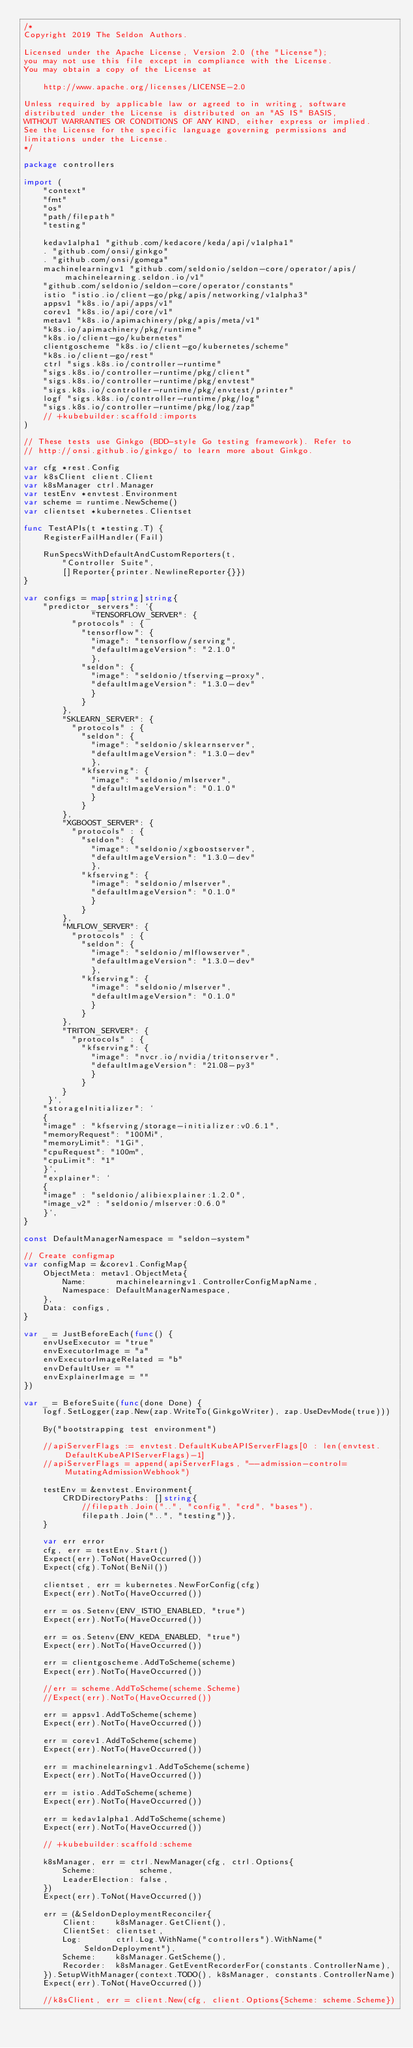Convert code to text. <code><loc_0><loc_0><loc_500><loc_500><_Go_>/*
Copyright 2019 The Seldon Authors.

Licensed under the Apache License, Version 2.0 (the "License");
you may not use this file except in compliance with the License.
You may obtain a copy of the License at

    http://www.apache.org/licenses/LICENSE-2.0

Unless required by applicable law or agreed to in writing, software
distributed under the License is distributed on an "AS IS" BASIS,
WITHOUT WARRANTIES OR CONDITIONS OF ANY KIND, either express or implied.
See the License for the specific language governing permissions and
limitations under the License.
*/

package controllers

import (
	"context"
	"fmt"
	"os"
	"path/filepath"
	"testing"

	kedav1alpha1 "github.com/kedacore/keda/api/v1alpha1"
	. "github.com/onsi/ginkgo"
	. "github.com/onsi/gomega"
	machinelearningv1 "github.com/seldonio/seldon-core/operator/apis/machinelearning.seldon.io/v1"
	"github.com/seldonio/seldon-core/operator/constants"
	istio "istio.io/client-go/pkg/apis/networking/v1alpha3"
	appsv1 "k8s.io/api/apps/v1"
	corev1 "k8s.io/api/core/v1"
	metav1 "k8s.io/apimachinery/pkg/apis/meta/v1"
	"k8s.io/apimachinery/pkg/runtime"
	"k8s.io/client-go/kubernetes"
	clientgoscheme "k8s.io/client-go/kubernetes/scheme"
	"k8s.io/client-go/rest"
	ctrl "sigs.k8s.io/controller-runtime"
	"sigs.k8s.io/controller-runtime/pkg/client"
	"sigs.k8s.io/controller-runtime/pkg/envtest"
	"sigs.k8s.io/controller-runtime/pkg/envtest/printer"
	logf "sigs.k8s.io/controller-runtime/pkg/log"
	"sigs.k8s.io/controller-runtime/pkg/log/zap"
	// +kubebuilder:scaffold:imports
)

// These tests use Ginkgo (BDD-style Go testing framework). Refer to
// http://onsi.github.io/ginkgo/ to learn more about Ginkgo.

var cfg *rest.Config
var k8sClient client.Client
var k8sManager ctrl.Manager
var testEnv *envtest.Environment
var scheme = runtime.NewScheme()
var clientset *kubernetes.Clientset

func TestAPIs(t *testing.T) {
	RegisterFailHandler(Fail)

	RunSpecsWithDefaultAndCustomReporters(t,
		"Controller Suite",
		[]Reporter{printer.NewlineReporter{}})
}

var configs = map[string]string{
	"predictor_servers": `{
              "TENSORFLOW_SERVER": {
          "protocols" : {
            "tensorflow": {
              "image": "tensorflow/serving",
              "defaultImageVersion": "2.1.0"
              },
            "seldon": {
              "image": "seldonio/tfserving-proxy",
              "defaultImageVersion": "1.3.0-dev"
              }
            }
        },
        "SKLEARN_SERVER": {
          "protocols" : {
            "seldon": {
              "image": "seldonio/sklearnserver",
              "defaultImageVersion": "1.3.0-dev"
              },
            "kfserving": {
              "image": "seldonio/mlserver",
              "defaultImageVersion": "0.1.0"
              }
            }
        },
        "XGBOOST_SERVER": {
          "protocols" : {
            "seldon": {
              "image": "seldonio/xgboostserver",
              "defaultImageVersion": "1.3.0-dev"
              },
            "kfserving": {
              "image": "seldonio/mlserver",
              "defaultImageVersion": "0.1.0"
              }
            }
        },
        "MLFLOW_SERVER": {
          "protocols" : {
            "seldon": {
              "image": "seldonio/mlflowserver",
              "defaultImageVersion": "1.3.0-dev"
              },
            "kfserving": {
              "image": "seldonio/mlserver",
              "defaultImageVersion": "0.1.0"
              }
            }
        },
        "TRITON_SERVER": {
          "protocols" : {
            "kfserving": {
              "image": "nvcr.io/nvidia/tritonserver",
              "defaultImageVersion": "21.08-py3"
              }
            }
        }
     }`,
	"storageInitializer": `
	{
	"image" : "kfserving/storage-initializer:v0.6.1",
	"memoryRequest": "100Mi",
	"memoryLimit": "1Gi",
	"cpuRequest": "100m",
	"cpuLimit": "1"
	}`,
	"explainer": `
	{
	"image" : "seldonio/alibiexplainer:1.2.0",
	"image_v2" : "seldonio/mlserver:0.6.0"
	}`,
}

const DefaultManagerNamespace = "seldon-system"

// Create configmap
var configMap = &corev1.ConfigMap{
	ObjectMeta: metav1.ObjectMeta{
		Name:      machinelearningv1.ControllerConfigMapName,
		Namespace: DefaultManagerNamespace,
	},
	Data: configs,
}

var _ = JustBeforeEach(func() {
	envUseExecutor = "true"
	envExecutorImage = "a"
	envExecutorImageRelated = "b"
	envDefaultUser = ""
	envExplainerImage = ""
})

var _ = BeforeSuite(func(done Done) {
	logf.SetLogger(zap.New(zap.WriteTo(GinkgoWriter), zap.UseDevMode(true)))

	By("bootstrapping test environment")

	//apiServerFlags := envtest.DefaultKubeAPIServerFlags[0 : len(envtest.DefaultKubeAPIServerFlags)-1]
	//apiServerFlags = append(apiServerFlags, "--admission-control=MutatingAdmissionWebhook")

	testEnv = &envtest.Environment{
		CRDDirectoryPaths: []string{
			//filepath.Join("..", "config", "crd", "bases"),
			filepath.Join("..", "testing")},
	}

	var err error
	cfg, err = testEnv.Start()
	Expect(err).ToNot(HaveOccurred())
	Expect(cfg).ToNot(BeNil())

	clientset, err = kubernetes.NewForConfig(cfg)
	Expect(err).NotTo(HaveOccurred())

	err = os.Setenv(ENV_ISTIO_ENABLED, "true")
	Expect(err).NotTo(HaveOccurred())

	err = os.Setenv(ENV_KEDA_ENABLED, "true")
	Expect(err).NotTo(HaveOccurred())

	err = clientgoscheme.AddToScheme(scheme)
	Expect(err).NotTo(HaveOccurred())

	//err = scheme.AddToScheme(scheme.Scheme)
	//Expect(err).NotTo(HaveOccurred())

	err = appsv1.AddToScheme(scheme)
	Expect(err).NotTo(HaveOccurred())

	err = corev1.AddToScheme(scheme)
	Expect(err).NotTo(HaveOccurred())

	err = machinelearningv1.AddToScheme(scheme)
	Expect(err).NotTo(HaveOccurred())

	err = istio.AddToScheme(scheme)
	Expect(err).NotTo(HaveOccurred())

	err = kedav1alpha1.AddToScheme(scheme)
	Expect(err).NotTo(HaveOccurred())

	// +kubebuilder:scaffold:scheme

	k8sManager, err = ctrl.NewManager(cfg, ctrl.Options{
		Scheme:         scheme,
		LeaderElection: false,
	})
	Expect(err).ToNot(HaveOccurred())

	err = (&SeldonDeploymentReconciler{
		Client:    k8sManager.GetClient(),
		ClientSet: clientset,
		Log:       ctrl.Log.WithName("controllers").WithName("SeldonDeployment"),
		Scheme:    k8sManager.GetScheme(),
		Recorder:  k8sManager.GetEventRecorderFor(constants.ControllerName),
	}).SetupWithManager(context.TODO(), k8sManager, constants.ControllerName)
	Expect(err).ToNot(HaveOccurred())

	//k8sClient, err = client.New(cfg, client.Options{Scheme: scheme.Scheme})</code> 